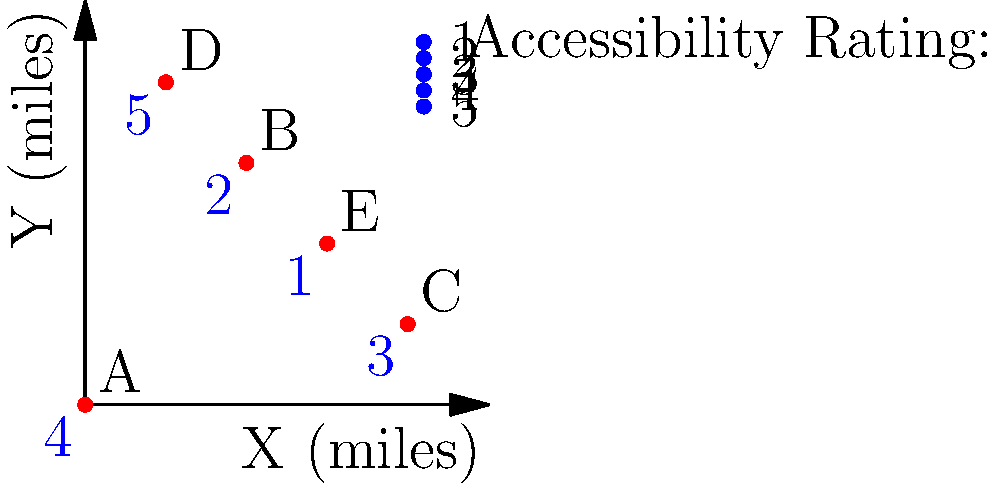Based on the map of polling locations and their accessibility ratings, which location would be the most challenging for voters with mobility issues to access, and what is its distance from the origin (0,0) in miles? To answer this question, we need to follow these steps:

1. Identify the location with the lowest accessibility rating:
   - Location A: 4
   - Location B: 2
   - Location C: 3
   - Location D: 5
   - Location E: 1
   Location E has the lowest rating of 1, making it the most challenging for voters with mobility issues.

2. Calculate the distance of Location E from the origin (0,0):
   - Coordinates of E: (3,2)
   - Use the distance formula: $d = \sqrt{(x_2-x_1)^2 + (y_2-y_1)^2}$
   - $d = \sqrt{(3-0)^2 + (2-0)^2}$
   - $d = \sqrt{9 + 4}$
   - $d = \sqrt{13}$
   - $d \approx 3.61$ miles

Therefore, Location E is the most challenging for voters with mobility issues, and it is approximately 3.61 miles from the origin.
Answer: Location E, $\sqrt{13}$ miles (≈3.61 miles) 